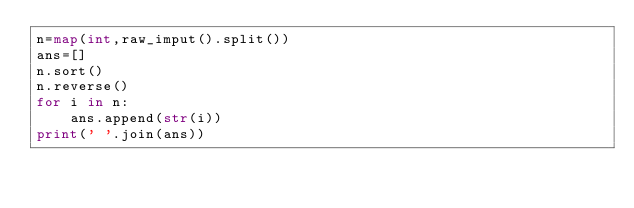<code> <loc_0><loc_0><loc_500><loc_500><_Python_>n=map(int,raw_imput().split())
ans=[]
n.sort()
n.reverse()
for i in n:
	ans.append(str(i))
print(' '.join(ans))</code> 